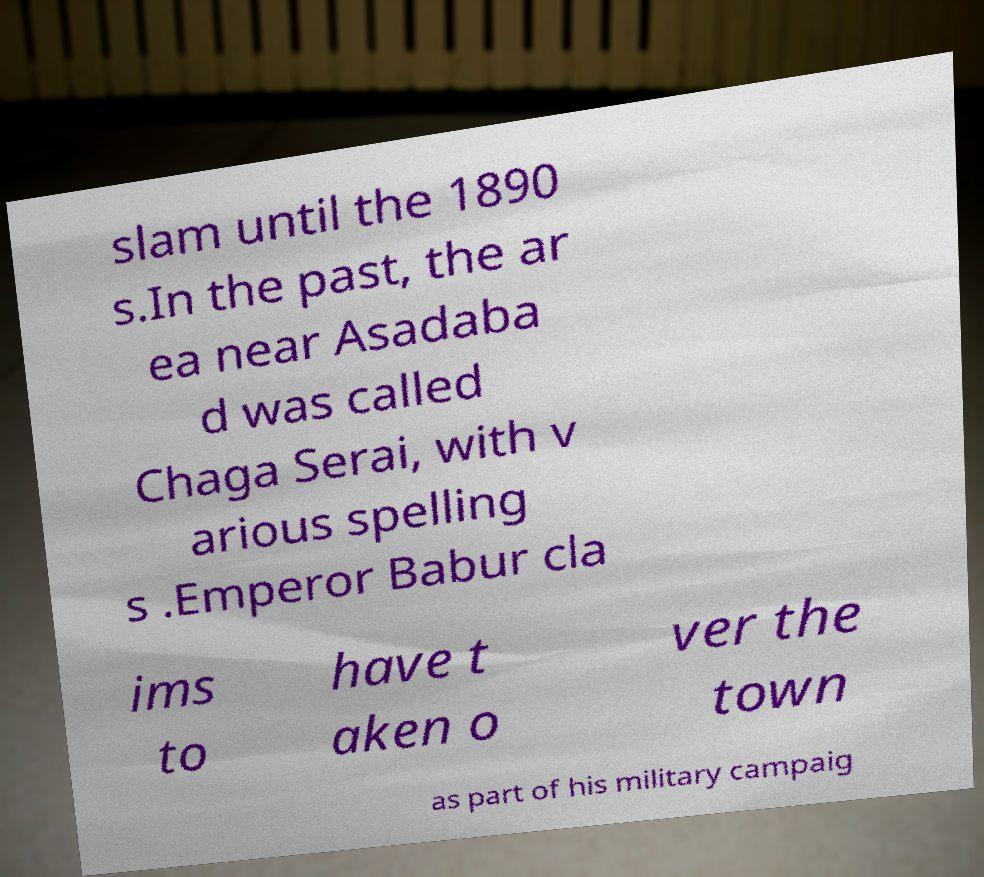Please identify and transcribe the text found in this image. slam until the 1890 s.In the past, the ar ea near Asadaba d was called Chaga Serai, with v arious spelling s .Emperor Babur cla ims to have t aken o ver the town as part of his military campaig 